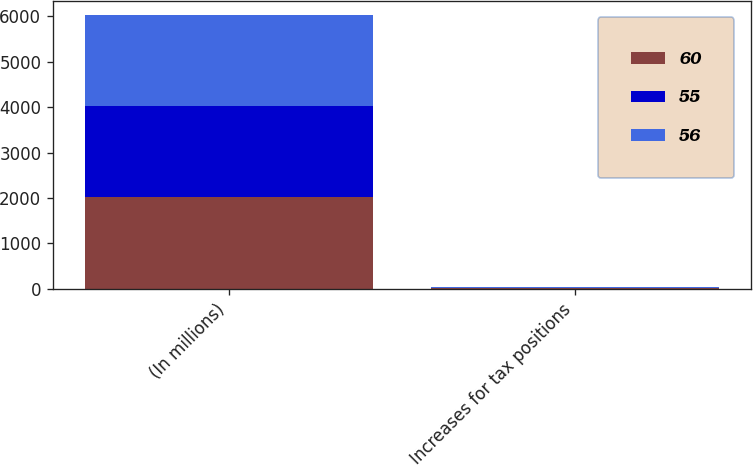Convert chart to OTSL. <chart><loc_0><loc_0><loc_500><loc_500><stacked_bar_chart><ecel><fcel>(In millions)<fcel>Increases for tax positions<nl><fcel>60<fcel>2014<fcel>10<nl><fcel>55<fcel>2013<fcel>6<nl><fcel>56<fcel>2012<fcel>19<nl></chart> 